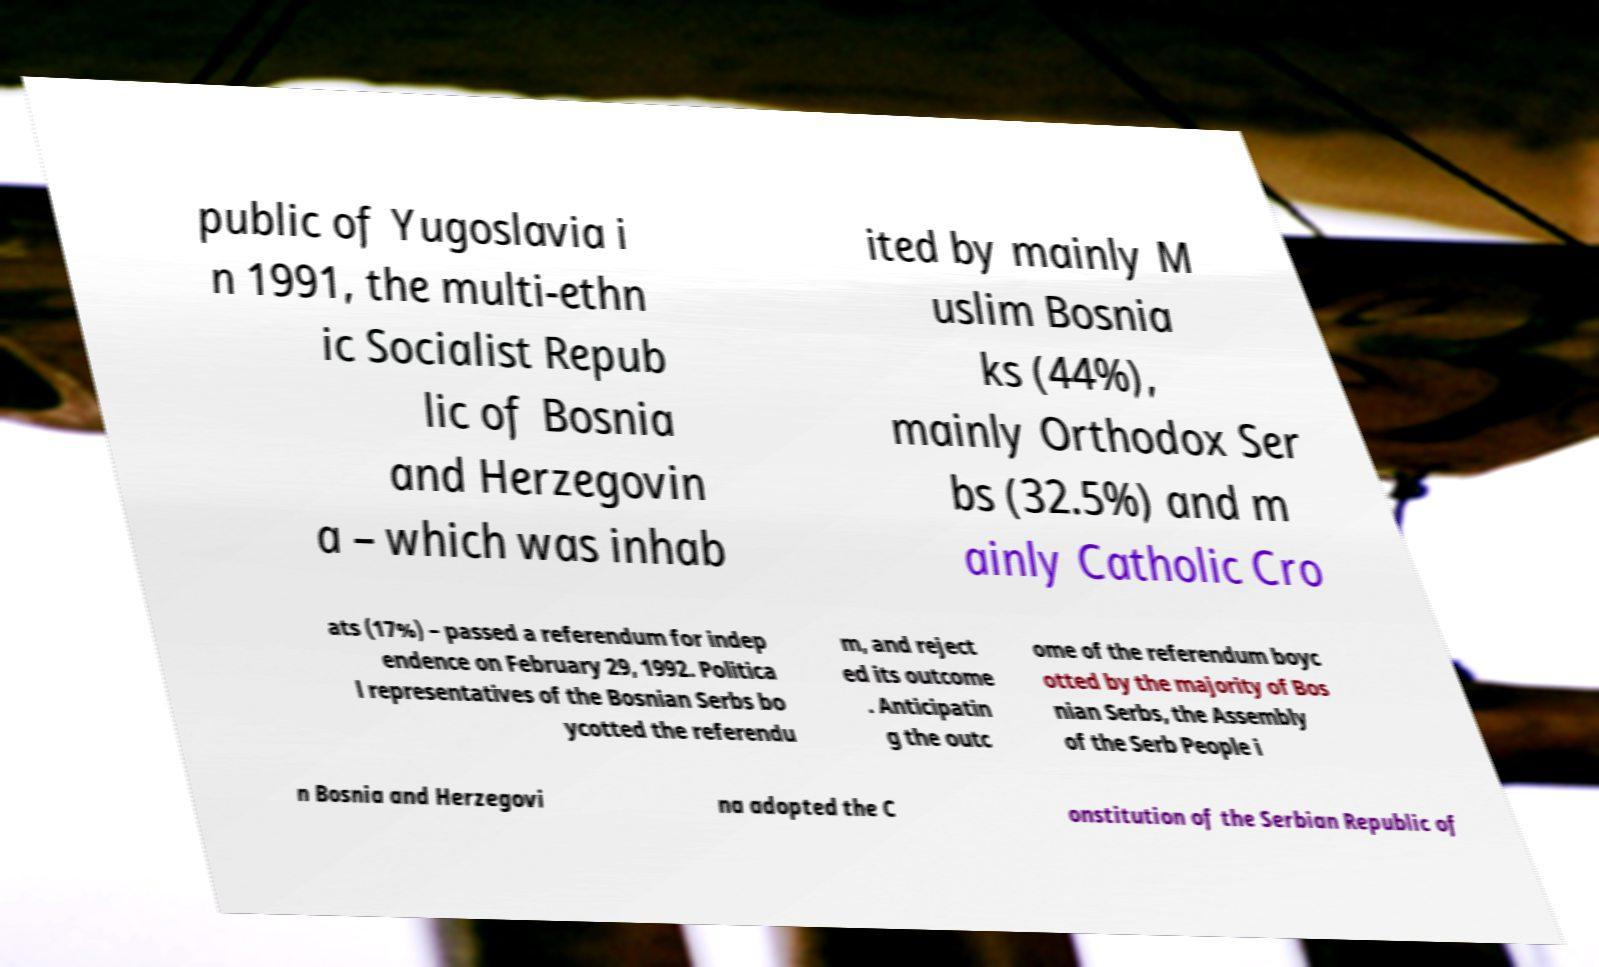There's text embedded in this image that I need extracted. Can you transcribe it verbatim? public of Yugoslavia i n 1991, the multi-ethn ic Socialist Repub lic of Bosnia and Herzegovin a – which was inhab ited by mainly M uslim Bosnia ks (44%), mainly Orthodox Ser bs (32.5%) and m ainly Catholic Cro ats (17%) – passed a referendum for indep endence on February 29, 1992. Politica l representatives of the Bosnian Serbs bo ycotted the referendu m, and reject ed its outcome . Anticipatin g the outc ome of the referendum boyc otted by the majority of Bos nian Serbs, the Assembly of the Serb People i n Bosnia and Herzegovi na adopted the C onstitution of the Serbian Republic of 